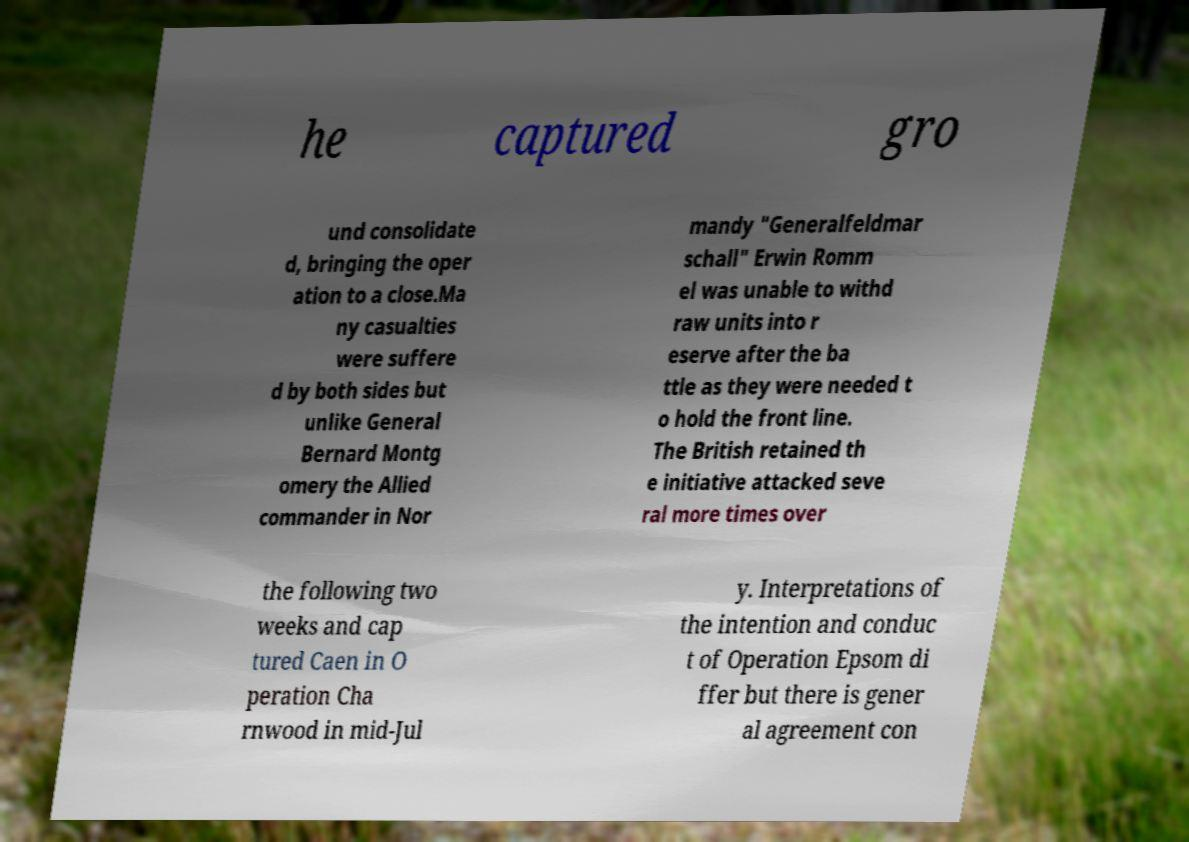For documentation purposes, I need the text within this image transcribed. Could you provide that? he captured gro und consolidate d, bringing the oper ation to a close.Ma ny casualties were suffere d by both sides but unlike General Bernard Montg omery the Allied commander in Nor mandy "Generalfeldmar schall" Erwin Romm el was unable to withd raw units into r eserve after the ba ttle as they were needed t o hold the front line. The British retained th e initiative attacked seve ral more times over the following two weeks and cap tured Caen in O peration Cha rnwood in mid-Jul y. Interpretations of the intention and conduc t of Operation Epsom di ffer but there is gener al agreement con 